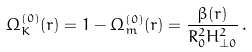Convert formula to latex. <formula><loc_0><loc_0><loc_500><loc_500>\Omega _ { K } ^ { ( 0 ) } ( r ) = 1 - \Omega _ { m } ^ { ( 0 ) } ( r ) = \frac { \beta ( r ) } { R _ { 0 } ^ { 2 } H _ { \perp 0 } ^ { 2 } } \, .</formula> 